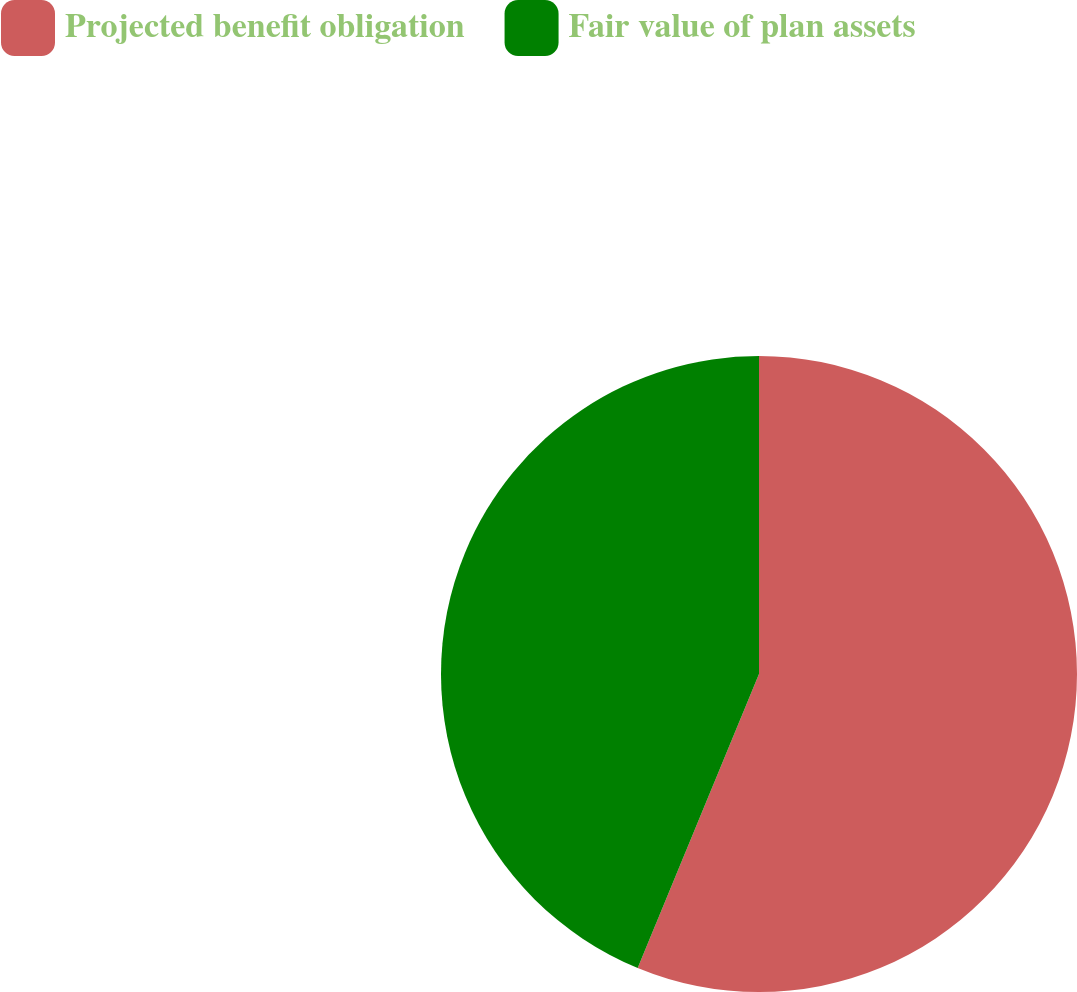Convert chart to OTSL. <chart><loc_0><loc_0><loc_500><loc_500><pie_chart><fcel>Projected benefit obligation<fcel>Fair value of plan assets<nl><fcel>56.23%<fcel>43.77%<nl></chart> 